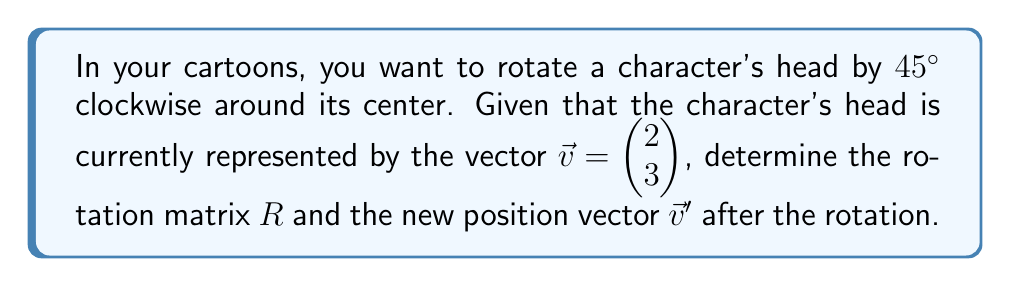Help me with this question. 1. The rotation matrix for a clockwise rotation by angle $\theta$ is given by:

   $$R = \begin{pmatrix} \cos\theta & \sin\theta \\ -\sin\theta & \cos\theta \end{pmatrix}$$

2. For a 45° rotation, $\theta = 45° = \frac{\pi}{4}$ radians. We know that:
   
   $\cos\frac{\pi}{4} = \sin\frac{\pi}{4} = \frac{\sqrt{2}}{2}$

3. Substituting these values into the rotation matrix:

   $$R = \begin{pmatrix} \frac{\sqrt{2}}{2} & \frac{\sqrt{2}}{2} \\ -\frac{\sqrt{2}}{2} & \frac{\sqrt{2}}{2} \end{pmatrix}$$

4. To find the new position vector $\vec{v}'$, we multiply $R$ by $\vec{v}$:

   $$\vec{v}' = R\vec{v} = \begin{pmatrix} \frac{\sqrt{2}}{2} & \frac{\sqrt{2}}{2} \\ -\frac{\sqrt{2}}{2} & \frac{\sqrt{2}}{2} \end{pmatrix} \begin{pmatrix} 2 \\ 3 \end{pmatrix}$$

5. Performing the matrix multiplication:

   $$\vec{v}' = \begin{pmatrix} \frac{\sqrt{2}}{2}(2) + \frac{\sqrt{2}}{2}(3) \\ -\frac{\sqrt{2}}{2}(2) + \frac{\sqrt{2}}{2}(3) \end{pmatrix} = \begin{pmatrix} \frac{5\sqrt{2}}{2} \\ \frac{\sqrt{2}}{2} \end{pmatrix}$$
Answer: $R = \begin{pmatrix} \frac{\sqrt{2}}{2} & \frac{\sqrt{2}}{2} \\ -\frac{\sqrt{2}}{2} & \frac{\sqrt{2}}{2} \end{pmatrix}$, $\vec{v}' = \begin{pmatrix} \frac{5\sqrt{2}}{2} \\ \frac{\sqrt{2}}{2} \end{pmatrix}$ 